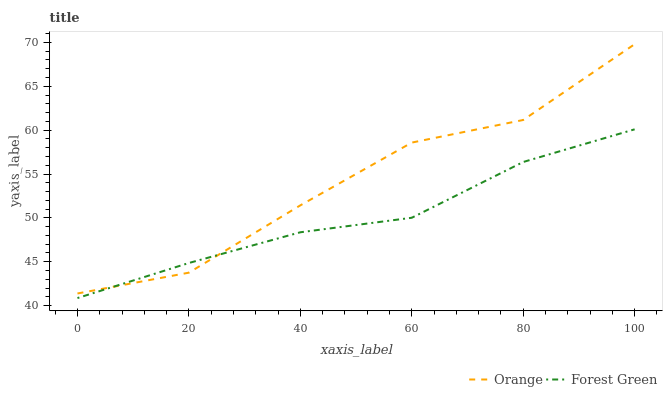Does Forest Green have the minimum area under the curve?
Answer yes or no. Yes. Does Orange have the maximum area under the curve?
Answer yes or no. Yes. Does Forest Green have the maximum area under the curve?
Answer yes or no. No. Is Forest Green the smoothest?
Answer yes or no. Yes. Is Orange the roughest?
Answer yes or no. Yes. Is Forest Green the roughest?
Answer yes or no. No. Does Forest Green have the lowest value?
Answer yes or no. Yes. Does Orange have the highest value?
Answer yes or no. Yes. Does Forest Green have the highest value?
Answer yes or no. No. Does Forest Green intersect Orange?
Answer yes or no. Yes. Is Forest Green less than Orange?
Answer yes or no. No. Is Forest Green greater than Orange?
Answer yes or no. No. 